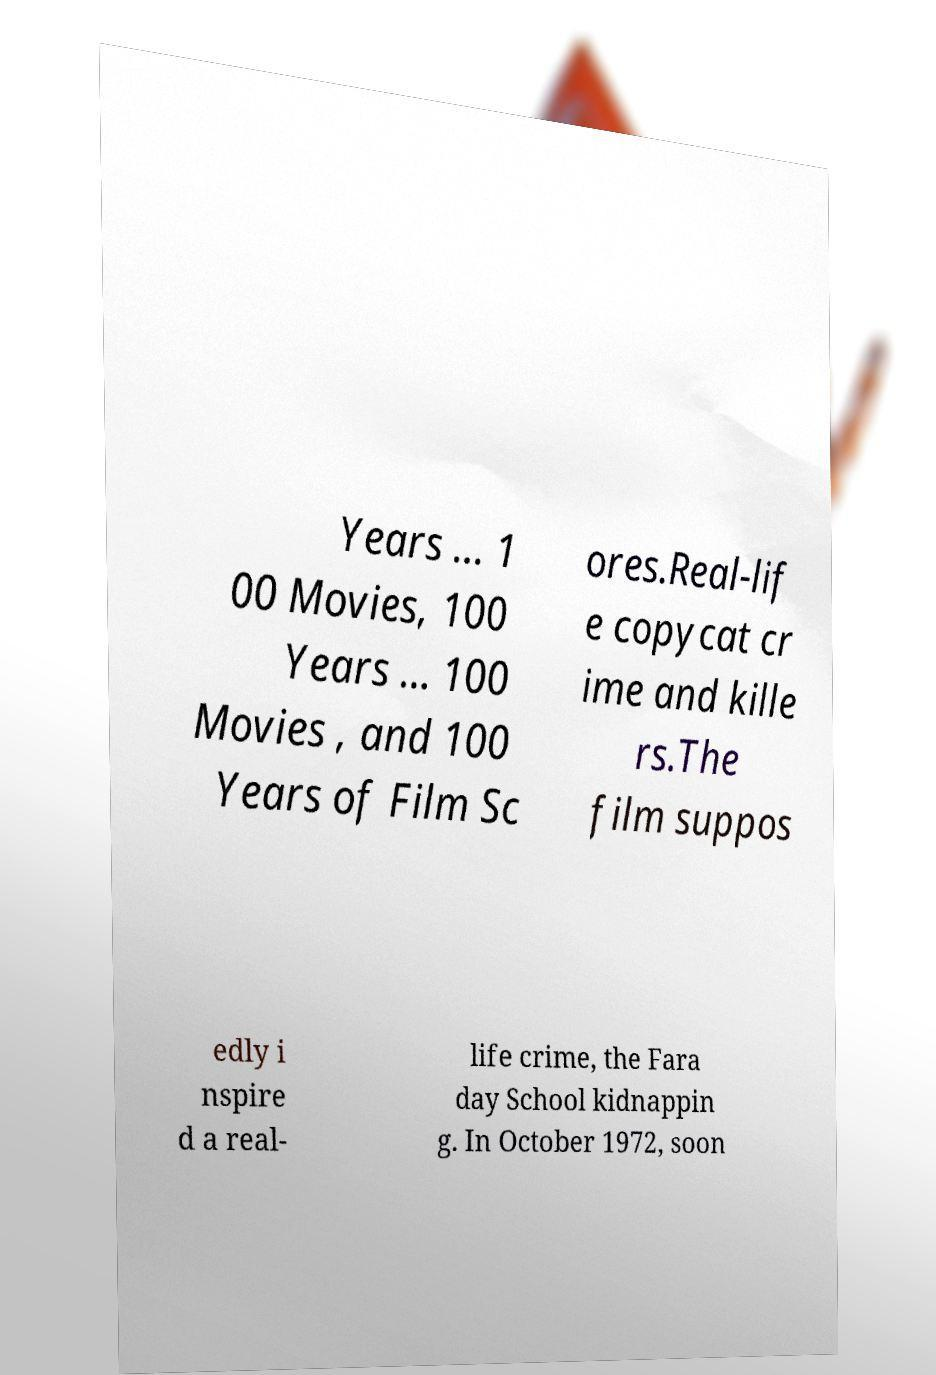Could you extract and type out the text from this image? Years ... 1 00 Movies, 100 Years ... 100 Movies , and 100 Years of Film Sc ores.Real-lif e copycat cr ime and kille rs.The film suppos edly i nspire d a real- life crime, the Fara day School kidnappin g. In October 1972, soon 